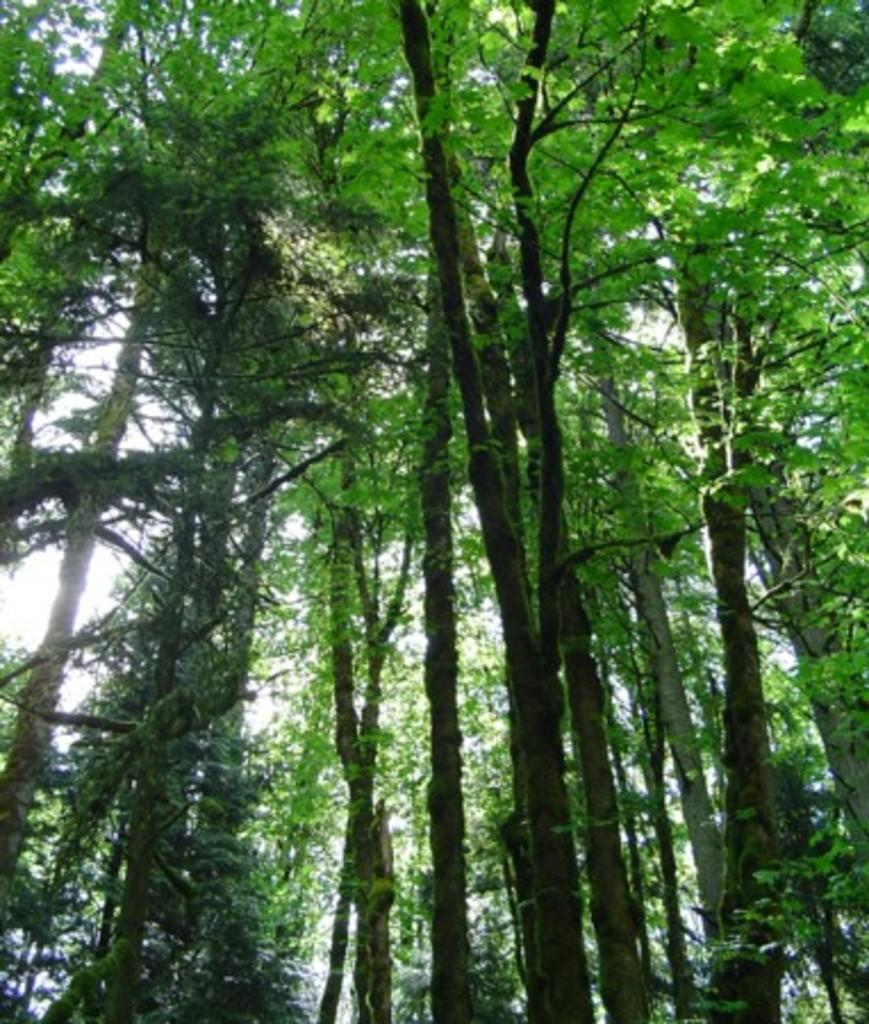What is visible in the background of the image? The sky is visible in the image. What can be seen in the sky in the image? Clouds are present in the image. What type of vegetation is visible in the image? Trees are visible in the image. Can you see the receipt from the store in the image? There is no receipt present in the image. What type of yarn is being used to create the clouds in the image? The image does not depict clouds being created with yarn; the clouds are natural formations in the sky. 